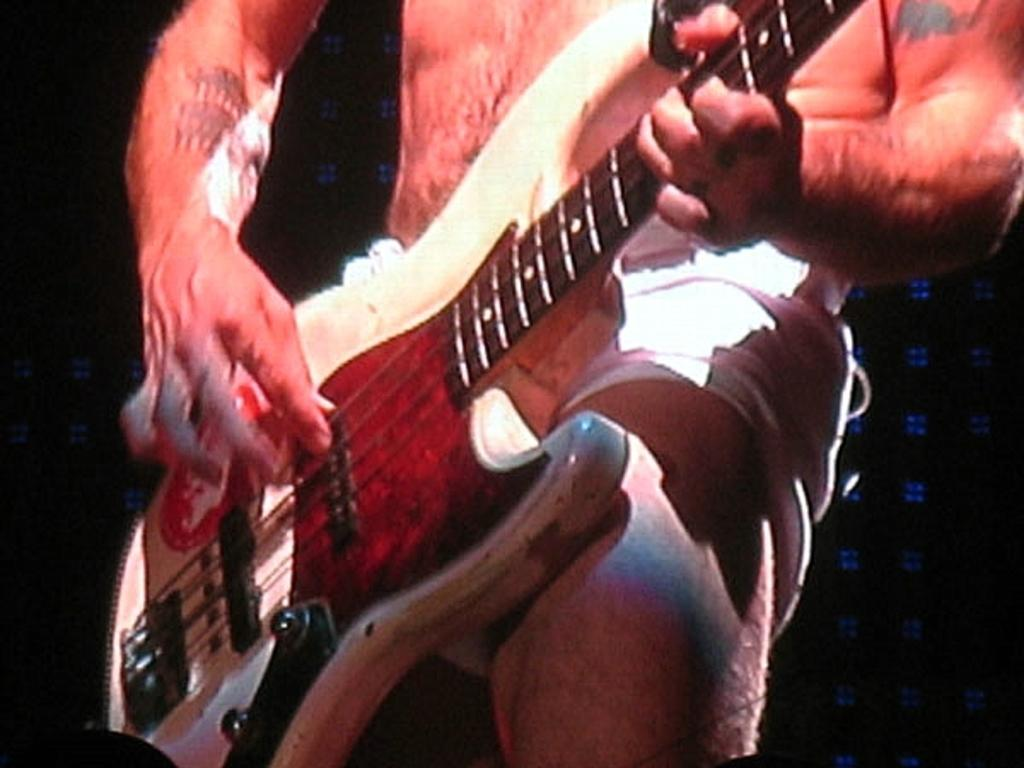What is the main subject of the image? There is a person in the image. What is the person holding in the image? The person is holding a guitar. What type of pets can be seen playing with a needle in the image? There are no pets or needles present in the image; it features a person holding a guitar. 